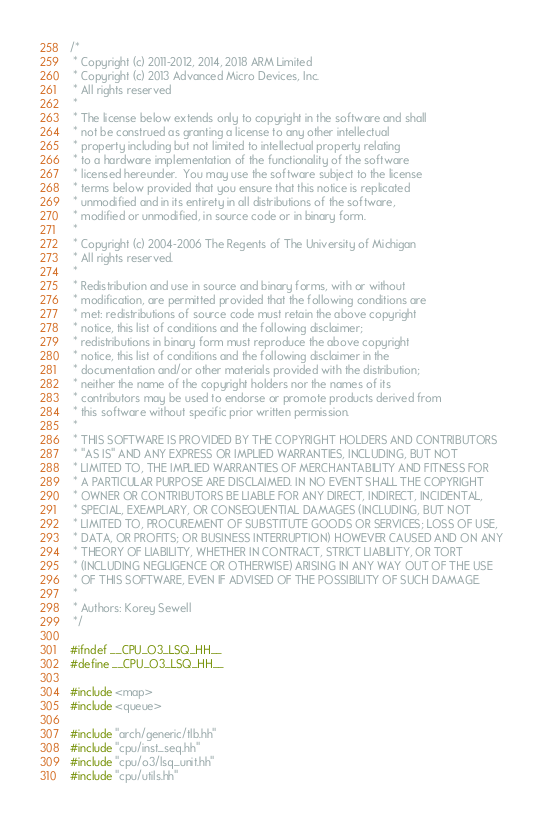<code> <loc_0><loc_0><loc_500><loc_500><_C++_>/*
 * Copyright (c) 2011-2012, 2014, 2018 ARM Limited
 * Copyright (c) 2013 Advanced Micro Devices, Inc.
 * All rights reserved
 *
 * The license below extends only to copyright in the software and shall
 * not be construed as granting a license to any other intellectual
 * property including but not limited to intellectual property relating
 * to a hardware implementation of the functionality of the software
 * licensed hereunder.  You may use the software subject to the license
 * terms below provided that you ensure that this notice is replicated
 * unmodified and in its entirety in all distributions of the software,
 * modified or unmodified, in source code or in binary form.
 *
 * Copyright (c) 2004-2006 The Regents of The University of Michigan
 * All rights reserved.
 *
 * Redistribution and use in source and binary forms, with or without
 * modification, are permitted provided that the following conditions are
 * met: redistributions of source code must retain the above copyright
 * notice, this list of conditions and the following disclaimer;
 * redistributions in binary form must reproduce the above copyright
 * notice, this list of conditions and the following disclaimer in the
 * documentation and/or other materials provided with the distribution;
 * neither the name of the copyright holders nor the names of its
 * contributors may be used to endorse or promote products derived from
 * this software without specific prior written permission.
 *
 * THIS SOFTWARE IS PROVIDED BY THE COPYRIGHT HOLDERS AND CONTRIBUTORS
 * "AS IS" AND ANY EXPRESS OR IMPLIED WARRANTIES, INCLUDING, BUT NOT
 * LIMITED TO, THE IMPLIED WARRANTIES OF MERCHANTABILITY AND FITNESS FOR
 * A PARTICULAR PURPOSE ARE DISCLAIMED. IN NO EVENT SHALL THE COPYRIGHT
 * OWNER OR CONTRIBUTORS BE LIABLE FOR ANY DIRECT, INDIRECT, INCIDENTAL,
 * SPECIAL, EXEMPLARY, OR CONSEQUENTIAL DAMAGES (INCLUDING, BUT NOT
 * LIMITED TO, PROCUREMENT OF SUBSTITUTE GOODS OR SERVICES; LOSS OF USE,
 * DATA, OR PROFITS; OR BUSINESS INTERRUPTION) HOWEVER CAUSED AND ON ANY
 * THEORY OF LIABILITY, WHETHER IN CONTRACT, STRICT LIABILITY, OR TORT
 * (INCLUDING NEGLIGENCE OR OTHERWISE) ARISING IN ANY WAY OUT OF THE USE
 * OF THIS SOFTWARE, EVEN IF ADVISED OF THE POSSIBILITY OF SUCH DAMAGE.
 *
 * Authors: Korey Sewell
 */

#ifndef __CPU_O3_LSQ_HH__
#define __CPU_O3_LSQ_HH__

#include <map>
#include <queue>

#include "arch/generic/tlb.hh"
#include "cpu/inst_seq.hh"
#include "cpu/o3/lsq_unit.hh"
#include "cpu/utils.hh"</code> 